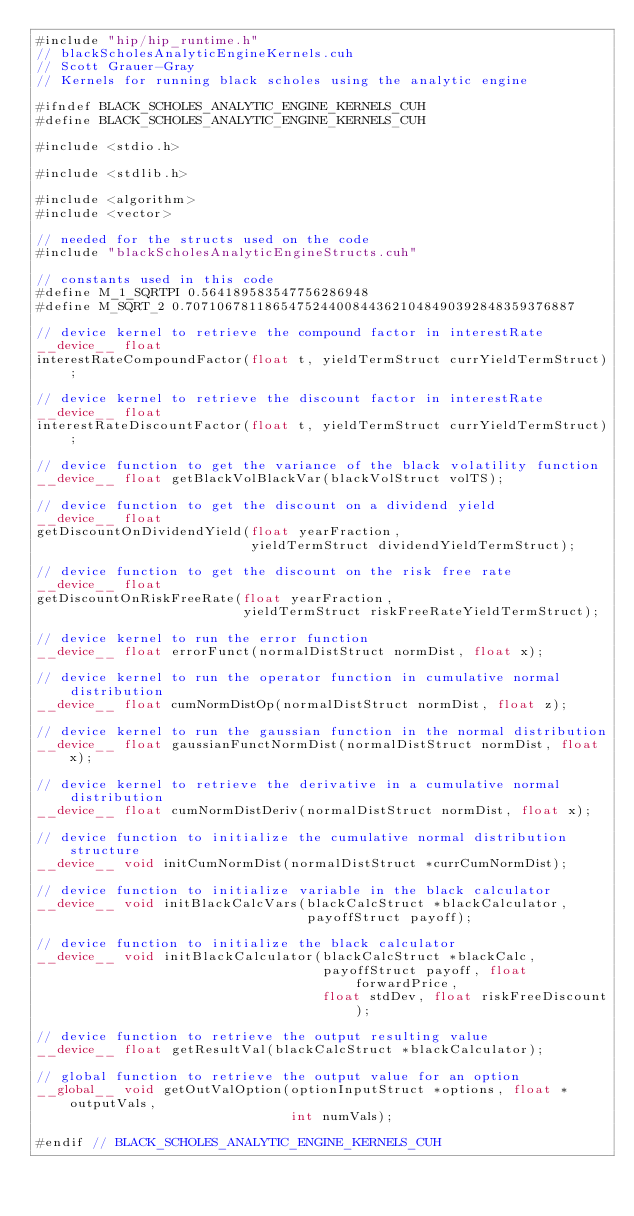Convert code to text. <code><loc_0><loc_0><loc_500><loc_500><_Cuda_>#include "hip/hip_runtime.h"
// blackScholesAnalyticEngineKernels.cuh
// Scott Grauer-Gray
// Kernels for running black scholes using the analytic engine

#ifndef BLACK_SCHOLES_ANALYTIC_ENGINE_KERNELS_CUH
#define BLACK_SCHOLES_ANALYTIC_ENGINE_KERNELS_CUH

#include <stdio.h>

#include <stdlib.h>

#include <algorithm>
#include <vector>

// needed for the structs used on the code
#include "blackScholesAnalyticEngineStructs.cuh"

// constants used in this code
#define M_1_SQRTPI 0.564189583547756286948
#define M_SQRT_2 0.7071067811865475244008443621048490392848359376887

// device kernel to retrieve the compound factor in interestRate
__device__ float
interestRateCompoundFactor(float t, yieldTermStruct currYieldTermStruct);

// device kernel to retrieve the discount factor in interestRate
__device__ float
interestRateDiscountFactor(float t, yieldTermStruct currYieldTermStruct);

// device function to get the variance of the black volatility function
__device__ float getBlackVolBlackVar(blackVolStruct volTS);

// device function to get the discount on a dividend yield
__device__ float
getDiscountOnDividendYield(float yearFraction,
                           yieldTermStruct dividendYieldTermStruct);

// device function to get the discount on the risk free rate
__device__ float
getDiscountOnRiskFreeRate(float yearFraction,
                          yieldTermStruct riskFreeRateYieldTermStruct);

// device kernel to run the error function
__device__ float errorFunct(normalDistStruct normDist, float x);

// device kernel to run the operator function in cumulative normal distribution
__device__ float cumNormDistOp(normalDistStruct normDist, float z);

// device kernel to run the gaussian function in the normal distribution
__device__ float gaussianFunctNormDist(normalDistStruct normDist, float x);

// device kernel to retrieve the derivative in a cumulative normal distribution
__device__ float cumNormDistDeriv(normalDistStruct normDist, float x);

// device function to initialize the cumulative normal distribution structure
__device__ void initCumNormDist(normalDistStruct *currCumNormDist);

// device function to initialize variable in the black calculator
__device__ void initBlackCalcVars(blackCalcStruct *blackCalculator,
                                  payoffStruct payoff);

// device function to initialize the black calculator
__device__ void initBlackCalculator(blackCalcStruct *blackCalc,
                                    payoffStruct payoff, float forwardPrice,
                                    float stdDev, float riskFreeDiscount);

// device function to retrieve the output resulting value
__device__ float getResultVal(blackCalcStruct *blackCalculator);

// global function to retrieve the output value for an option
__global__ void getOutValOption(optionInputStruct *options, float *outputVals,
                                int numVals);

#endif // BLACK_SCHOLES_ANALYTIC_ENGINE_KERNELS_CUH
</code> 